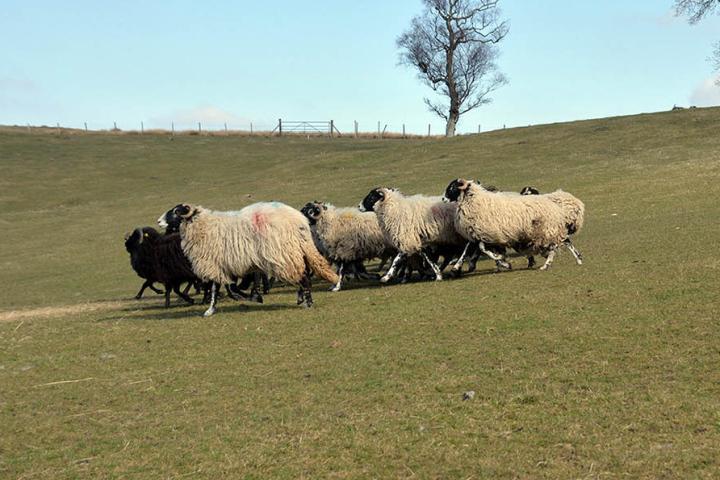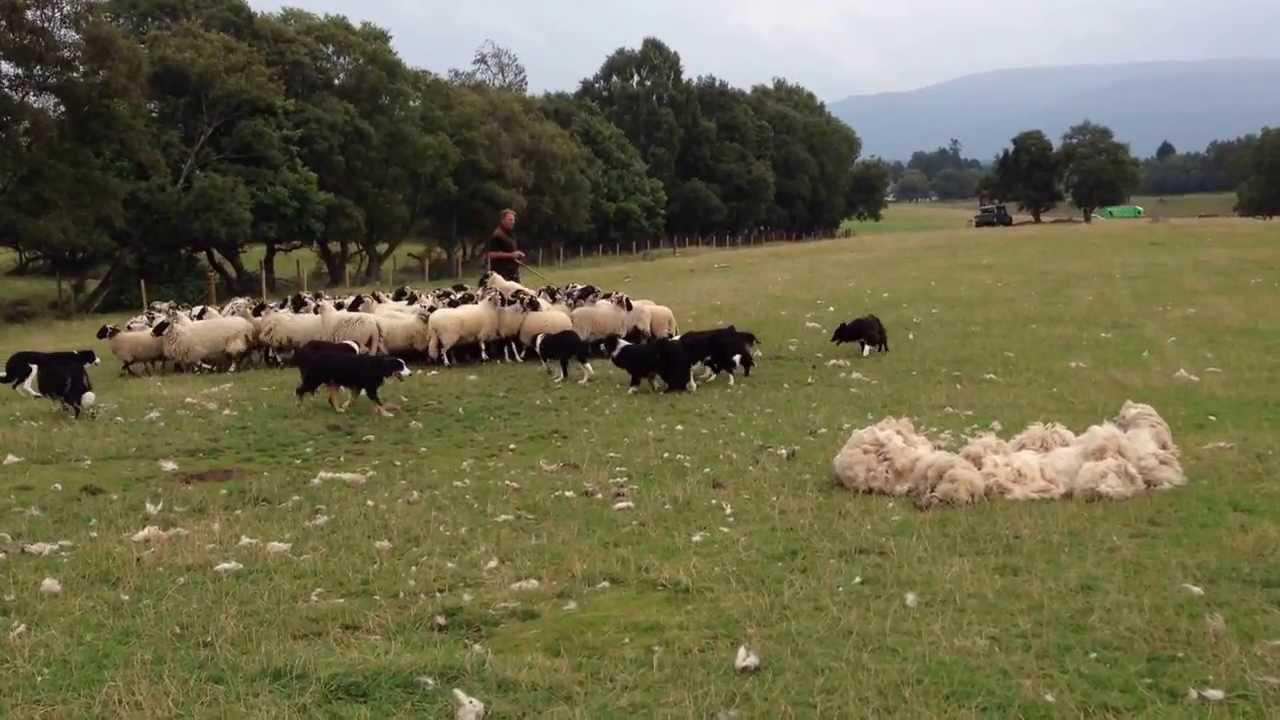The first image is the image on the left, the second image is the image on the right. Analyze the images presented: Is the assertion "In the right image, there's a single dog herding some sheep on its own." valid? Answer yes or no. No. 